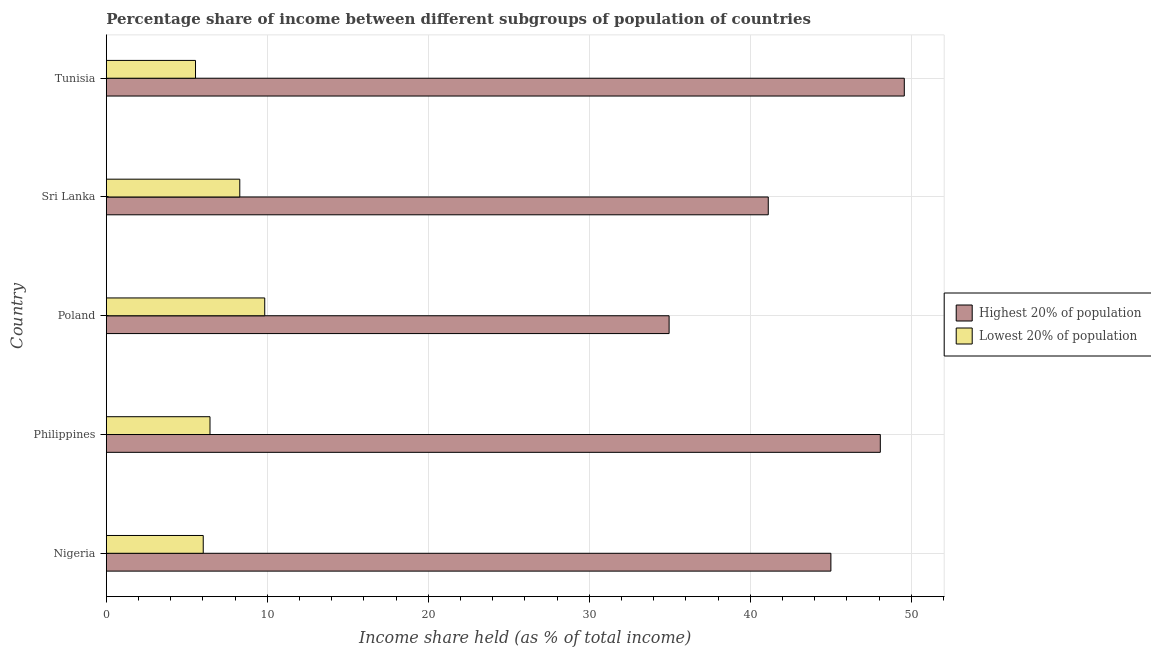How many different coloured bars are there?
Offer a terse response. 2. How many groups of bars are there?
Provide a succinct answer. 5. How many bars are there on the 2nd tick from the top?
Ensure brevity in your answer.  2. In how many cases, is the number of bars for a given country not equal to the number of legend labels?
Make the answer very short. 0. What is the income share held by lowest 20% of the population in Poland?
Your answer should be compact. 9.84. Across all countries, what is the maximum income share held by highest 20% of the population?
Keep it short and to the point. 49.57. Across all countries, what is the minimum income share held by highest 20% of the population?
Offer a terse response. 34.96. In which country was the income share held by highest 20% of the population maximum?
Your answer should be compact. Tunisia. In which country was the income share held by highest 20% of the population minimum?
Make the answer very short. Poland. What is the total income share held by lowest 20% of the population in the graph?
Offer a terse response. 36.13. What is the difference between the income share held by highest 20% of the population in Philippines and that in Poland?
Give a very brief answer. 13.12. What is the difference between the income share held by lowest 20% of the population in Philippines and the income share held by highest 20% of the population in Nigeria?
Give a very brief answer. -38.57. What is the average income share held by highest 20% of the population per country?
Your response must be concise. 43.75. What is the difference between the income share held by lowest 20% of the population and income share held by highest 20% of the population in Poland?
Give a very brief answer. -25.12. In how many countries, is the income share held by highest 20% of the population greater than 8 %?
Your response must be concise. 5. What is the ratio of the income share held by lowest 20% of the population in Nigeria to that in Philippines?
Offer a very short reply. 0.94. Is the income share held by highest 20% of the population in Nigeria less than that in Tunisia?
Provide a succinct answer. Yes. What is the difference between the highest and the second highest income share held by highest 20% of the population?
Offer a terse response. 1.49. What is the difference between the highest and the lowest income share held by highest 20% of the population?
Make the answer very short. 14.61. In how many countries, is the income share held by lowest 20% of the population greater than the average income share held by lowest 20% of the population taken over all countries?
Keep it short and to the point. 2. What does the 2nd bar from the top in Philippines represents?
Provide a short and direct response. Highest 20% of population. What does the 2nd bar from the bottom in Poland represents?
Keep it short and to the point. Lowest 20% of population. How many countries are there in the graph?
Keep it short and to the point. 5. What is the difference between two consecutive major ticks on the X-axis?
Ensure brevity in your answer.  10. Are the values on the major ticks of X-axis written in scientific E-notation?
Provide a short and direct response. No. Does the graph contain any zero values?
Provide a short and direct response. No. Does the graph contain grids?
Ensure brevity in your answer.  Yes. How many legend labels are there?
Keep it short and to the point. 2. What is the title of the graph?
Your answer should be compact. Percentage share of income between different subgroups of population of countries. Does "Exports of goods" appear as one of the legend labels in the graph?
Provide a succinct answer. No. What is the label or title of the X-axis?
Your answer should be compact. Income share held (as % of total income). What is the label or title of the Y-axis?
Your answer should be compact. Country. What is the Income share held (as % of total income) of Highest 20% of population in Nigeria?
Make the answer very short. 45.01. What is the Income share held (as % of total income) of Lowest 20% of population in Nigeria?
Offer a very short reply. 6.02. What is the Income share held (as % of total income) in Highest 20% of population in Philippines?
Offer a very short reply. 48.08. What is the Income share held (as % of total income) in Lowest 20% of population in Philippines?
Ensure brevity in your answer.  6.44. What is the Income share held (as % of total income) in Highest 20% of population in Poland?
Your response must be concise. 34.96. What is the Income share held (as % of total income) in Lowest 20% of population in Poland?
Make the answer very short. 9.84. What is the Income share held (as % of total income) of Highest 20% of population in Sri Lanka?
Ensure brevity in your answer.  41.12. What is the Income share held (as % of total income) in Lowest 20% of population in Sri Lanka?
Offer a very short reply. 8.29. What is the Income share held (as % of total income) in Highest 20% of population in Tunisia?
Your answer should be compact. 49.57. What is the Income share held (as % of total income) in Lowest 20% of population in Tunisia?
Ensure brevity in your answer.  5.54. Across all countries, what is the maximum Income share held (as % of total income) in Highest 20% of population?
Keep it short and to the point. 49.57. Across all countries, what is the maximum Income share held (as % of total income) in Lowest 20% of population?
Ensure brevity in your answer.  9.84. Across all countries, what is the minimum Income share held (as % of total income) in Highest 20% of population?
Your response must be concise. 34.96. Across all countries, what is the minimum Income share held (as % of total income) in Lowest 20% of population?
Provide a succinct answer. 5.54. What is the total Income share held (as % of total income) in Highest 20% of population in the graph?
Make the answer very short. 218.74. What is the total Income share held (as % of total income) of Lowest 20% of population in the graph?
Provide a succinct answer. 36.13. What is the difference between the Income share held (as % of total income) of Highest 20% of population in Nigeria and that in Philippines?
Offer a very short reply. -3.07. What is the difference between the Income share held (as % of total income) in Lowest 20% of population in Nigeria and that in Philippines?
Keep it short and to the point. -0.42. What is the difference between the Income share held (as % of total income) of Highest 20% of population in Nigeria and that in Poland?
Offer a very short reply. 10.05. What is the difference between the Income share held (as % of total income) of Lowest 20% of population in Nigeria and that in Poland?
Your answer should be compact. -3.82. What is the difference between the Income share held (as % of total income) in Highest 20% of population in Nigeria and that in Sri Lanka?
Ensure brevity in your answer.  3.89. What is the difference between the Income share held (as % of total income) in Lowest 20% of population in Nigeria and that in Sri Lanka?
Your answer should be very brief. -2.27. What is the difference between the Income share held (as % of total income) of Highest 20% of population in Nigeria and that in Tunisia?
Provide a succinct answer. -4.56. What is the difference between the Income share held (as % of total income) of Lowest 20% of population in Nigeria and that in Tunisia?
Provide a succinct answer. 0.48. What is the difference between the Income share held (as % of total income) of Highest 20% of population in Philippines and that in Poland?
Give a very brief answer. 13.12. What is the difference between the Income share held (as % of total income) of Lowest 20% of population in Philippines and that in Poland?
Your response must be concise. -3.4. What is the difference between the Income share held (as % of total income) of Highest 20% of population in Philippines and that in Sri Lanka?
Give a very brief answer. 6.96. What is the difference between the Income share held (as % of total income) of Lowest 20% of population in Philippines and that in Sri Lanka?
Offer a terse response. -1.85. What is the difference between the Income share held (as % of total income) in Highest 20% of population in Philippines and that in Tunisia?
Offer a very short reply. -1.49. What is the difference between the Income share held (as % of total income) of Lowest 20% of population in Philippines and that in Tunisia?
Provide a succinct answer. 0.9. What is the difference between the Income share held (as % of total income) in Highest 20% of population in Poland and that in Sri Lanka?
Make the answer very short. -6.16. What is the difference between the Income share held (as % of total income) of Lowest 20% of population in Poland and that in Sri Lanka?
Give a very brief answer. 1.55. What is the difference between the Income share held (as % of total income) in Highest 20% of population in Poland and that in Tunisia?
Give a very brief answer. -14.61. What is the difference between the Income share held (as % of total income) in Lowest 20% of population in Poland and that in Tunisia?
Your answer should be compact. 4.3. What is the difference between the Income share held (as % of total income) in Highest 20% of population in Sri Lanka and that in Tunisia?
Keep it short and to the point. -8.45. What is the difference between the Income share held (as % of total income) of Lowest 20% of population in Sri Lanka and that in Tunisia?
Provide a short and direct response. 2.75. What is the difference between the Income share held (as % of total income) of Highest 20% of population in Nigeria and the Income share held (as % of total income) of Lowest 20% of population in Philippines?
Offer a terse response. 38.57. What is the difference between the Income share held (as % of total income) in Highest 20% of population in Nigeria and the Income share held (as % of total income) in Lowest 20% of population in Poland?
Make the answer very short. 35.17. What is the difference between the Income share held (as % of total income) in Highest 20% of population in Nigeria and the Income share held (as % of total income) in Lowest 20% of population in Sri Lanka?
Your response must be concise. 36.72. What is the difference between the Income share held (as % of total income) of Highest 20% of population in Nigeria and the Income share held (as % of total income) of Lowest 20% of population in Tunisia?
Provide a short and direct response. 39.47. What is the difference between the Income share held (as % of total income) in Highest 20% of population in Philippines and the Income share held (as % of total income) in Lowest 20% of population in Poland?
Your answer should be compact. 38.24. What is the difference between the Income share held (as % of total income) of Highest 20% of population in Philippines and the Income share held (as % of total income) of Lowest 20% of population in Sri Lanka?
Offer a terse response. 39.79. What is the difference between the Income share held (as % of total income) of Highest 20% of population in Philippines and the Income share held (as % of total income) of Lowest 20% of population in Tunisia?
Make the answer very short. 42.54. What is the difference between the Income share held (as % of total income) of Highest 20% of population in Poland and the Income share held (as % of total income) of Lowest 20% of population in Sri Lanka?
Give a very brief answer. 26.67. What is the difference between the Income share held (as % of total income) of Highest 20% of population in Poland and the Income share held (as % of total income) of Lowest 20% of population in Tunisia?
Provide a short and direct response. 29.42. What is the difference between the Income share held (as % of total income) of Highest 20% of population in Sri Lanka and the Income share held (as % of total income) of Lowest 20% of population in Tunisia?
Make the answer very short. 35.58. What is the average Income share held (as % of total income) in Highest 20% of population per country?
Provide a succinct answer. 43.75. What is the average Income share held (as % of total income) in Lowest 20% of population per country?
Your response must be concise. 7.23. What is the difference between the Income share held (as % of total income) of Highest 20% of population and Income share held (as % of total income) of Lowest 20% of population in Nigeria?
Provide a succinct answer. 38.99. What is the difference between the Income share held (as % of total income) in Highest 20% of population and Income share held (as % of total income) in Lowest 20% of population in Philippines?
Provide a succinct answer. 41.64. What is the difference between the Income share held (as % of total income) of Highest 20% of population and Income share held (as % of total income) of Lowest 20% of population in Poland?
Your response must be concise. 25.12. What is the difference between the Income share held (as % of total income) of Highest 20% of population and Income share held (as % of total income) of Lowest 20% of population in Sri Lanka?
Make the answer very short. 32.83. What is the difference between the Income share held (as % of total income) in Highest 20% of population and Income share held (as % of total income) in Lowest 20% of population in Tunisia?
Your answer should be compact. 44.03. What is the ratio of the Income share held (as % of total income) in Highest 20% of population in Nigeria to that in Philippines?
Your response must be concise. 0.94. What is the ratio of the Income share held (as % of total income) in Lowest 20% of population in Nigeria to that in Philippines?
Provide a short and direct response. 0.93. What is the ratio of the Income share held (as % of total income) in Highest 20% of population in Nigeria to that in Poland?
Offer a terse response. 1.29. What is the ratio of the Income share held (as % of total income) of Lowest 20% of population in Nigeria to that in Poland?
Provide a succinct answer. 0.61. What is the ratio of the Income share held (as % of total income) in Highest 20% of population in Nigeria to that in Sri Lanka?
Offer a terse response. 1.09. What is the ratio of the Income share held (as % of total income) in Lowest 20% of population in Nigeria to that in Sri Lanka?
Provide a succinct answer. 0.73. What is the ratio of the Income share held (as % of total income) of Highest 20% of population in Nigeria to that in Tunisia?
Offer a terse response. 0.91. What is the ratio of the Income share held (as % of total income) in Lowest 20% of population in Nigeria to that in Tunisia?
Give a very brief answer. 1.09. What is the ratio of the Income share held (as % of total income) of Highest 20% of population in Philippines to that in Poland?
Your response must be concise. 1.38. What is the ratio of the Income share held (as % of total income) of Lowest 20% of population in Philippines to that in Poland?
Provide a succinct answer. 0.65. What is the ratio of the Income share held (as % of total income) of Highest 20% of population in Philippines to that in Sri Lanka?
Give a very brief answer. 1.17. What is the ratio of the Income share held (as % of total income) of Lowest 20% of population in Philippines to that in Sri Lanka?
Offer a terse response. 0.78. What is the ratio of the Income share held (as % of total income) in Highest 20% of population in Philippines to that in Tunisia?
Your answer should be very brief. 0.97. What is the ratio of the Income share held (as % of total income) of Lowest 20% of population in Philippines to that in Tunisia?
Provide a short and direct response. 1.16. What is the ratio of the Income share held (as % of total income) in Highest 20% of population in Poland to that in Sri Lanka?
Offer a terse response. 0.85. What is the ratio of the Income share held (as % of total income) of Lowest 20% of population in Poland to that in Sri Lanka?
Provide a short and direct response. 1.19. What is the ratio of the Income share held (as % of total income) in Highest 20% of population in Poland to that in Tunisia?
Your answer should be very brief. 0.71. What is the ratio of the Income share held (as % of total income) of Lowest 20% of population in Poland to that in Tunisia?
Provide a short and direct response. 1.78. What is the ratio of the Income share held (as % of total income) in Highest 20% of population in Sri Lanka to that in Tunisia?
Keep it short and to the point. 0.83. What is the ratio of the Income share held (as % of total income) of Lowest 20% of population in Sri Lanka to that in Tunisia?
Give a very brief answer. 1.5. What is the difference between the highest and the second highest Income share held (as % of total income) in Highest 20% of population?
Provide a succinct answer. 1.49. What is the difference between the highest and the second highest Income share held (as % of total income) in Lowest 20% of population?
Provide a succinct answer. 1.55. What is the difference between the highest and the lowest Income share held (as % of total income) in Highest 20% of population?
Your response must be concise. 14.61. 